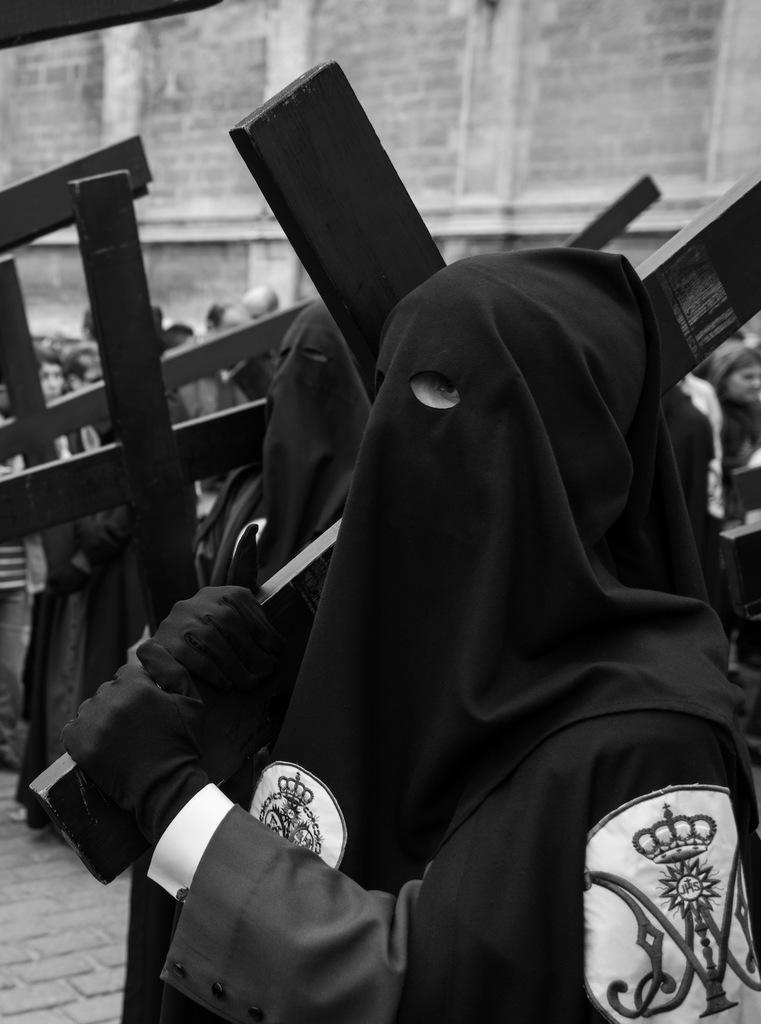In one or two sentences, can you explain what this image depicts? In the foreground of this image, there is a man in black dress holding a cross symbolize structure in his hand. In the background, there is the crowd and the wall. 